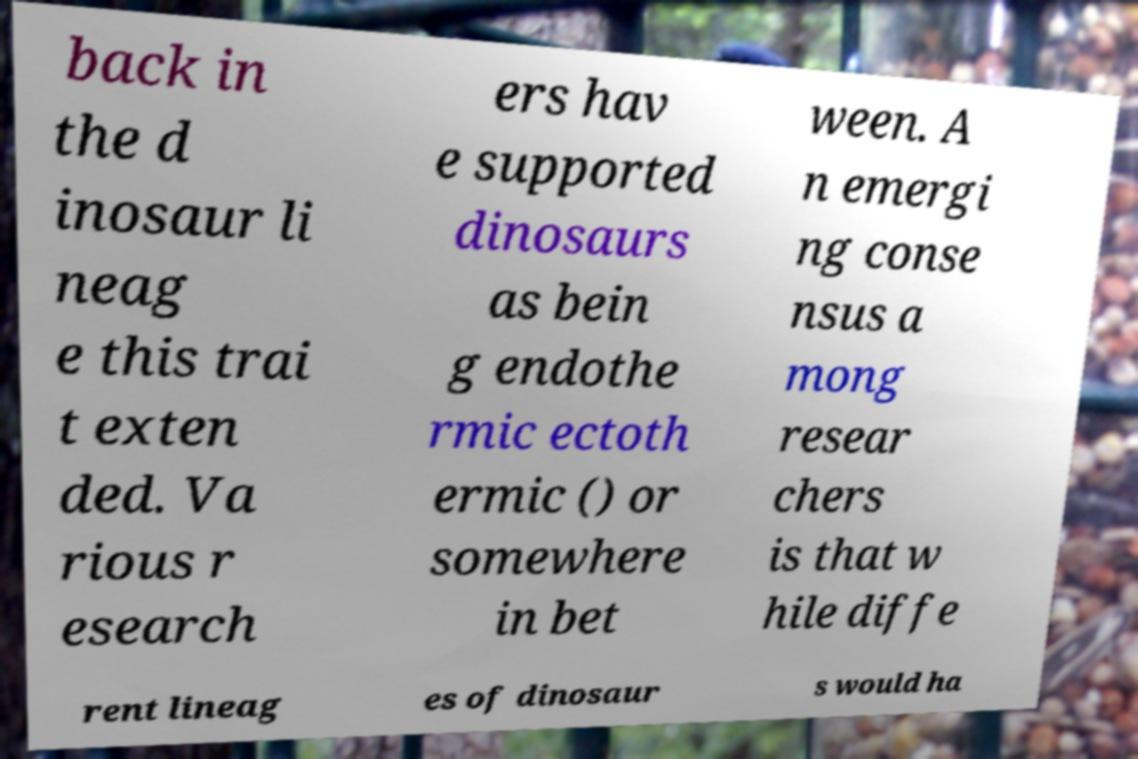Could you extract and type out the text from this image? back in the d inosaur li neag e this trai t exten ded. Va rious r esearch ers hav e supported dinosaurs as bein g endothe rmic ectoth ermic () or somewhere in bet ween. A n emergi ng conse nsus a mong resear chers is that w hile diffe rent lineag es of dinosaur s would ha 